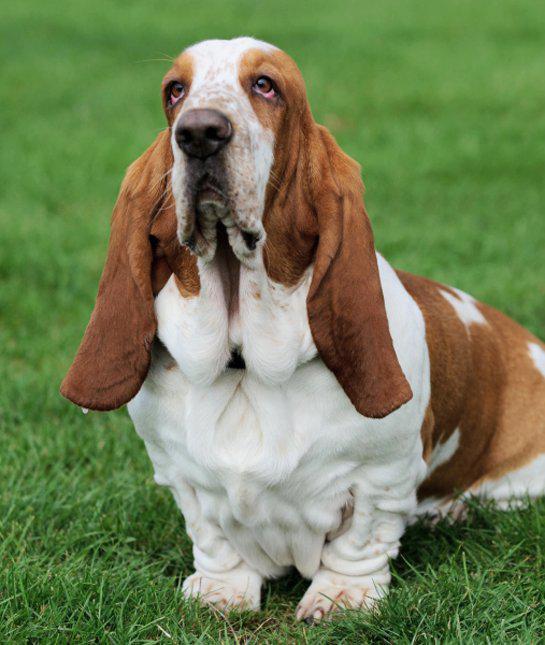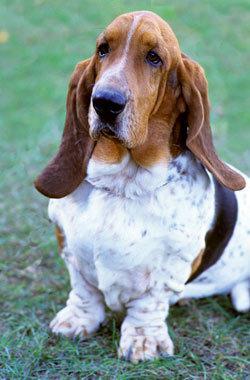The first image is the image on the left, the second image is the image on the right. Considering the images on both sides, is "Right and left images contain the same number of dogs." valid? Answer yes or no. Yes. 